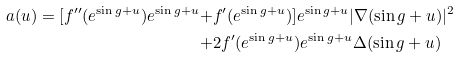<formula> <loc_0><loc_0><loc_500><loc_500>a ( u ) = [ f ^ { \prime \prime } ( e ^ { \sin g + u } ) e ^ { \sin g + u } + & f ^ { \prime } ( e ^ { \sin g + u } ) ] e ^ { \sin g + u } | \nabla ( \sin g + u ) | ^ { 2 } \\ + & 2 f ^ { \prime } ( e ^ { \sin g + u } ) e ^ { \sin g + u } \Delta ( \sin g + u )</formula> 